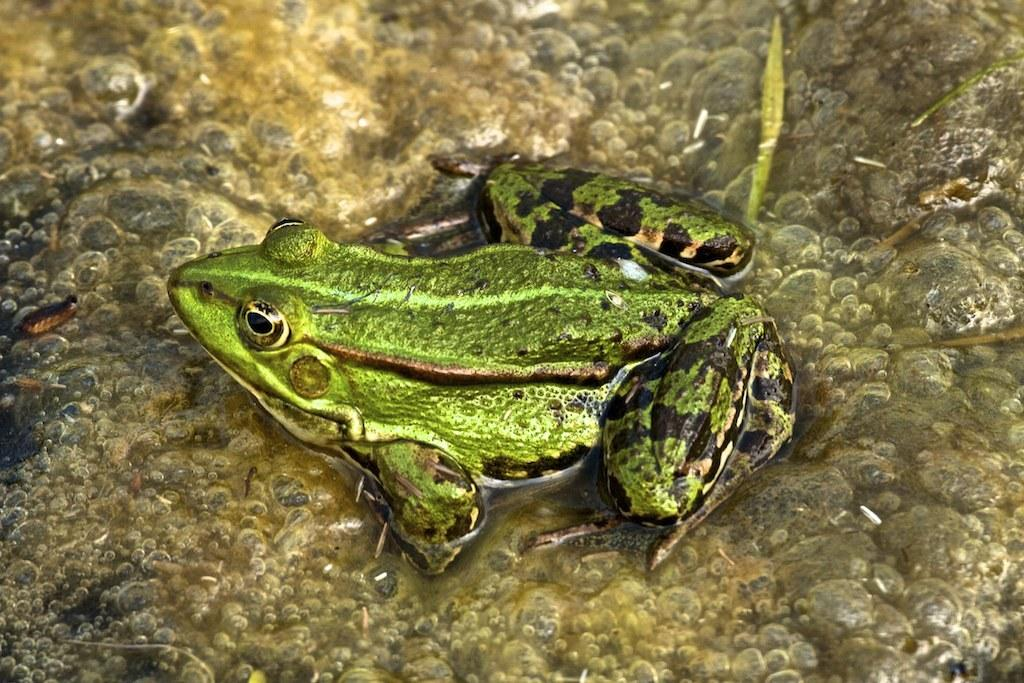What animal is in the water in the image? There is a frog in the water in the image. What else can be seen in the image besides the frog? There are some objects in the image. What type of bat is flying over the stranger in the image? There is no bat or stranger present in the image; it only features a frog in the water and some objects. 